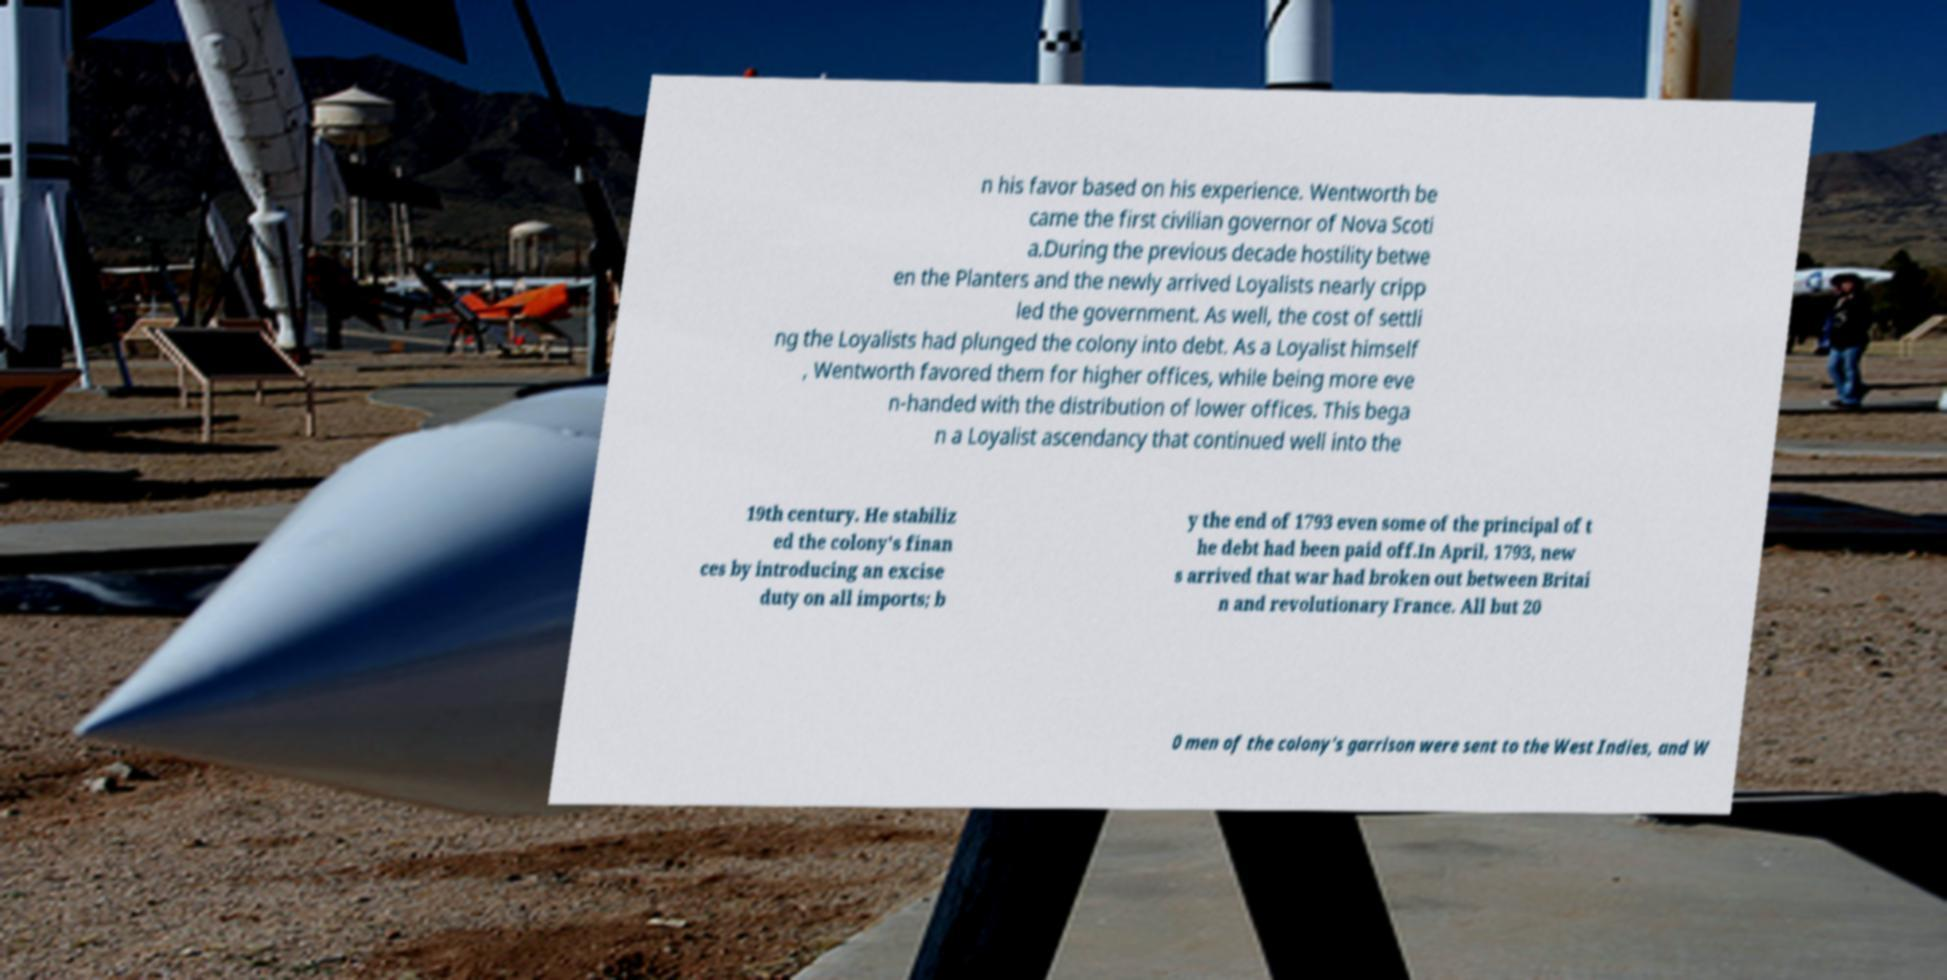Please read and relay the text visible in this image. What does it say? n his favor based on his experience. Wentworth be came the first civilian governor of Nova Scoti a.During the previous decade hostility betwe en the Planters and the newly arrived Loyalists nearly cripp led the government. As well, the cost of settli ng the Loyalists had plunged the colony into debt. As a Loyalist himself , Wentworth favored them for higher offices, while being more eve n-handed with the distribution of lower offices. This bega n a Loyalist ascendancy that continued well into the 19th century. He stabiliz ed the colony's finan ces by introducing an excise duty on all imports; b y the end of 1793 even some of the principal of t he debt had been paid off.In April, 1793, new s arrived that war had broken out between Britai n and revolutionary France. All but 20 0 men of the colony's garrison were sent to the West Indies, and W 